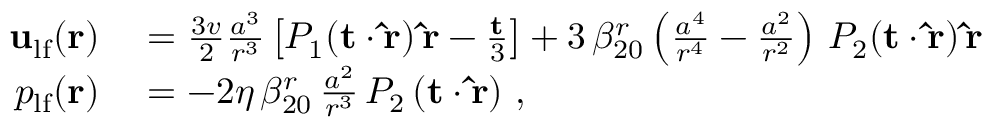Convert formula to latex. <formula><loc_0><loc_0><loc_500><loc_500>\begin{array} { r l } { { u } _ { l f } ( { r } ) } & = \frac { 3 v } { 2 } \frac { a ^ { 3 } } { r ^ { 3 } } \left [ P _ { 1 } ( { t } \cdot { \hat { r } } ) \, { \hat { r } } - \frac { t } { 3 } \right ] + 3 \, \beta _ { 2 0 } ^ { r } \left ( \frac { a ^ { 4 } } { r ^ { 4 } } - \frac { a ^ { 2 } } { r ^ { 2 } } \right ) \, P _ { 2 } ( { t } \cdot { \hat { r } } ) \, { \hat { r } } } \\ { p _ { l f } ( { r } ) } & = - 2 \eta \, \beta _ { 2 0 } ^ { r } \, \frac { a ^ { 2 } } { r ^ { 3 } } \, P _ { 2 } \left ( { t } \cdot { \hat { r } } \right ) \, , } \end{array}</formula> 